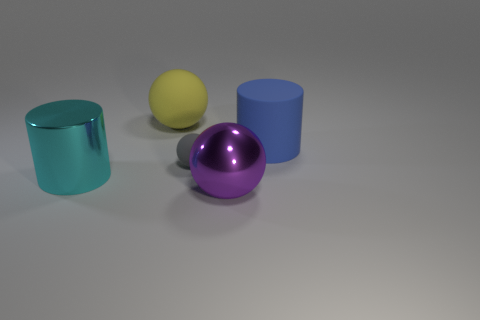Subtract all large balls. How many balls are left? 1 Add 4 red shiny things. How many objects exist? 9 Subtract all balls. How many objects are left? 2 Subtract all purple balls. Subtract all small rubber blocks. How many objects are left? 4 Add 1 purple things. How many purple things are left? 2 Add 1 blue rubber blocks. How many blue rubber blocks exist? 1 Subtract 1 yellow spheres. How many objects are left? 4 Subtract all yellow balls. Subtract all purple cylinders. How many balls are left? 2 